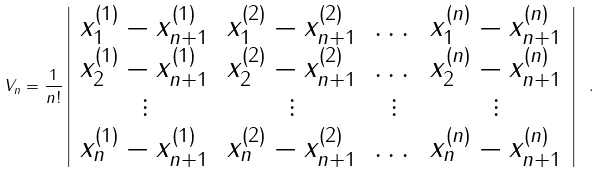Convert formula to latex. <formula><loc_0><loc_0><loc_500><loc_500>V _ { n } = \frac { 1 } { n ! } \left | \begin{array} { c c c c } x _ { 1 } ^ { ( 1 ) } - x _ { n + 1 } ^ { ( 1 ) } & x _ { 1 } ^ { ( 2 ) } - x _ { n + 1 } ^ { ( 2 ) } & \dots & x _ { 1 } ^ { ( n ) } - x _ { n + 1 } ^ { ( n ) } \\ x _ { 2 } ^ { ( 1 ) } - x _ { n + 1 } ^ { ( 1 ) } & x _ { 2 } ^ { ( 2 ) } - x _ { n + 1 } ^ { ( 2 ) } & \dots & x _ { 2 } ^ { ( n ) } - x _ { n + 1 } ^ { ( n ) } \\ \vdots & \vdots & \vdots & \vdots \\ x _ { n } ^ { ( 1 ) } - x _ { n + 1 } ^ { ( 1 ) } & x _ { n } ^ { ( 2 ) } - x _ { n + 1 } ^ { ( 2 ) } & \dots & x _ { n } ^ { ( n ) } - x _ { n + 1 } ^ { ( n ) } \end{array} \right | \ .</formula> 